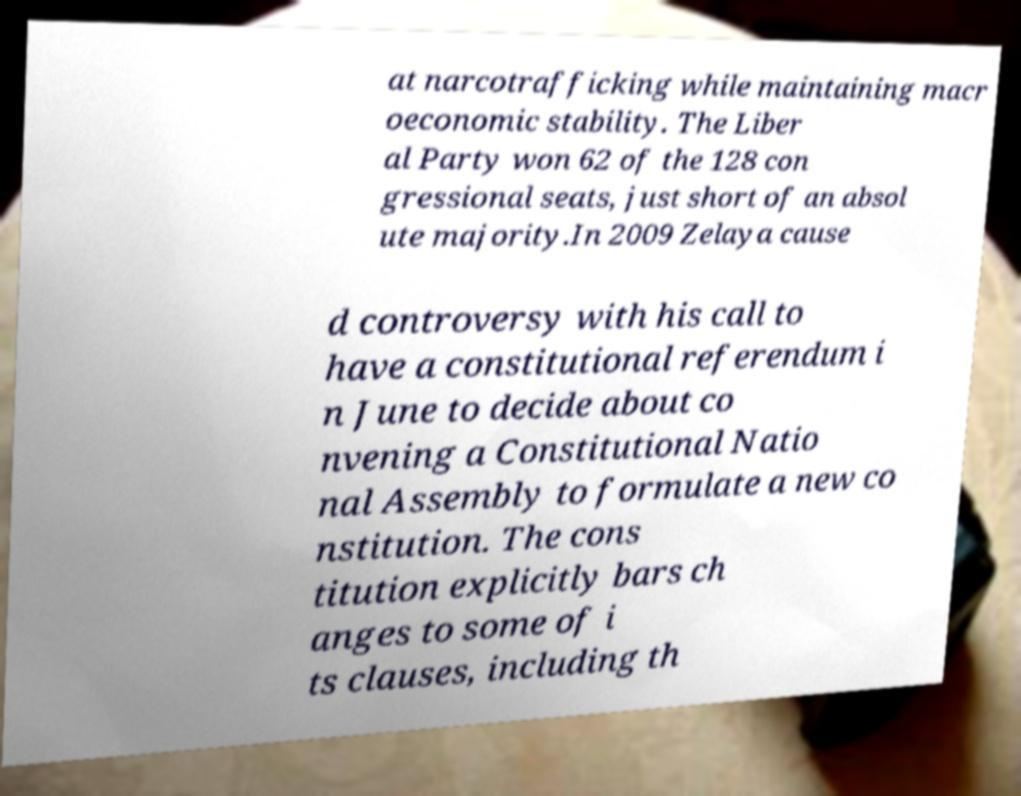Please read and relay the text visible in this image. What does it say? at narcotrafficking while maintaining macr oeconomic stability. The Liber al Party won 62 of the 128 con gressional seats, just short of an absol ute majority.In 2009 Zelaya cause d controversy with his call to have a constitutional referendum i n June to decide about co nvening a Constitutional Natio nal Assembly to formulate a new co nstitution. The cons titution explicitly bars ch anges to some of i ts clauses, including th 